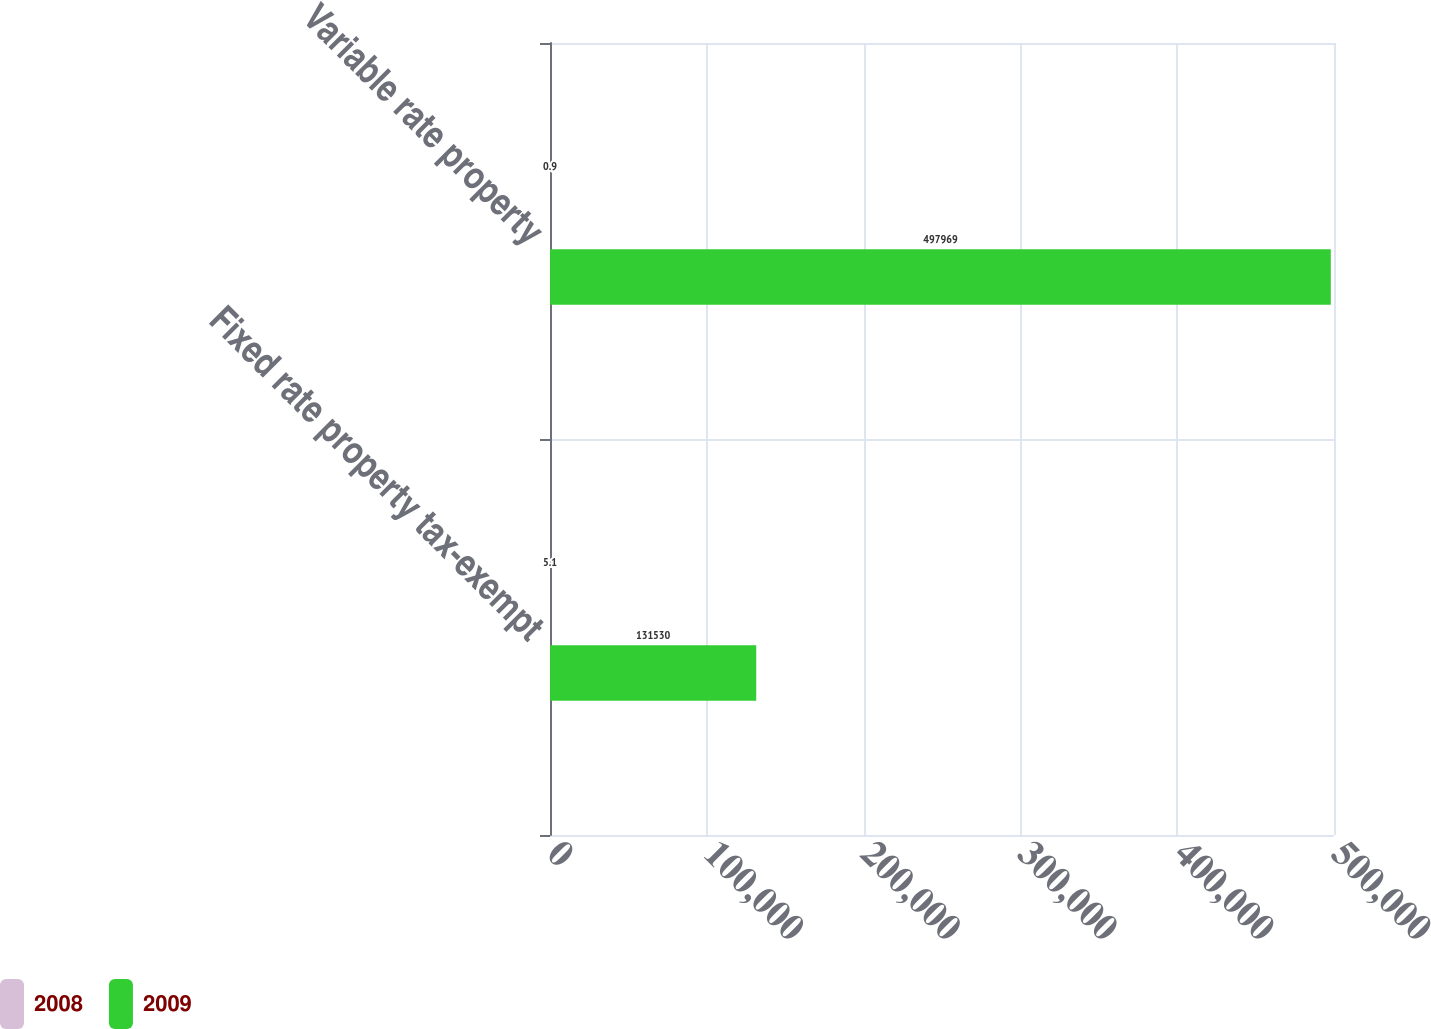Convert chart to OTSL. <chart><loc_0><loc_0><loc_500><loc_500><stacked_bar_chart><ecel><fcel>Fixed rate property tax-exempt<fcel>Variable rate property<nl><fcel>2008<fcel>5.1<fcel>0.9<nl><fcel>2009<fcel>131530<fcel>497969<nl></chart> 